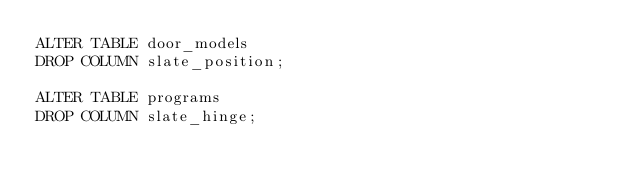<code> <loc_0><loc_0><loc_500><loc_500><_SQL_>ALTER TABLE door_models
DROP COLUMN slate_position;

ALTER TABLE programs
DROP COLUMN slate_hinge;
</code> 